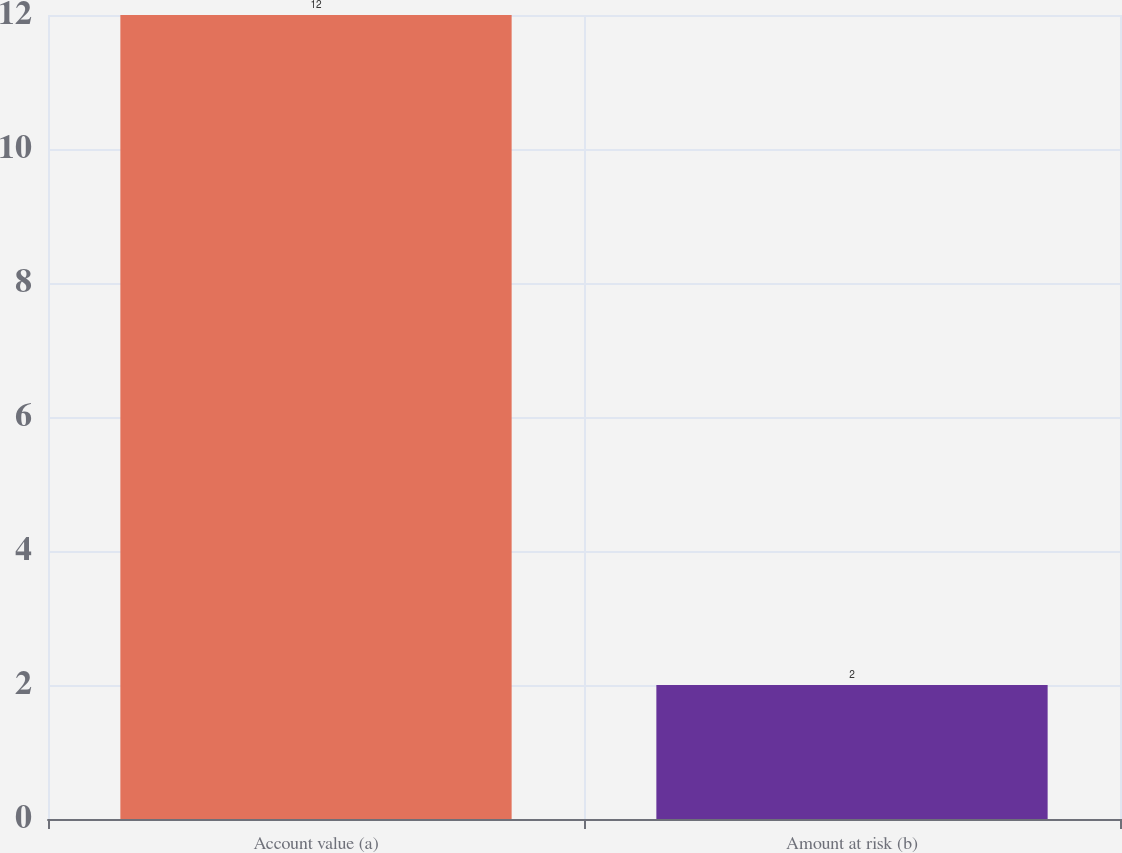Convert chart to OTSL. <chart><loc_0><loc_0><loc_500><loc_500><bar_chart><fcel>Account value (a)<fcel>Amount at risk (b)<nl><fcel>12<fcel>2<nl></chart> 